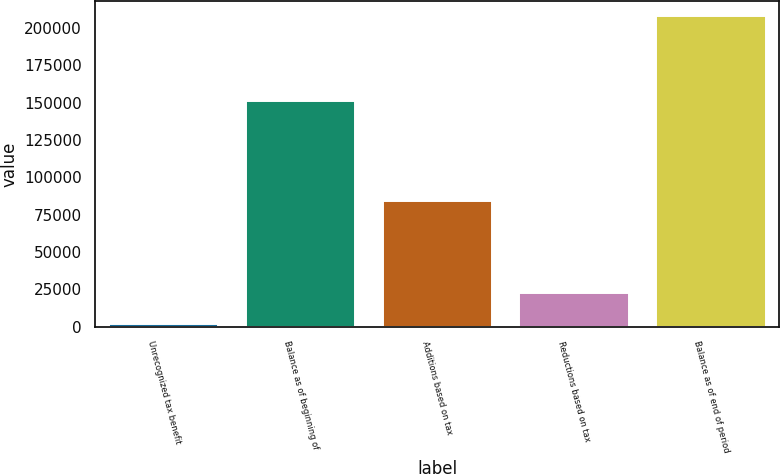Convert chart to OTSL. <chart><loc_0><loc_0><loc_500><loc_500><bar_chart><fcel>Unrecognized tax benefit<fcel>Balance as of beginning of<fcel>Additions based on tax<fcel>Reductions based on tax<fcel>Balance as of end of period<nl><fcel>2014<fcel>151353<fcel>84278.4<fcel>22580.1<fcel>207675<nl></chart> 